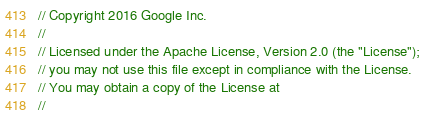<code> <loc_0><loc_0><loc_500><loc_500><_Java_>// Copyright 2016 Google Inc.
//
// Licensed under the Apache License, Version 2.0 (the "License");
// you may not use this file except in compliance with the License.
// You may obtain a copy of the License at
//</code> 